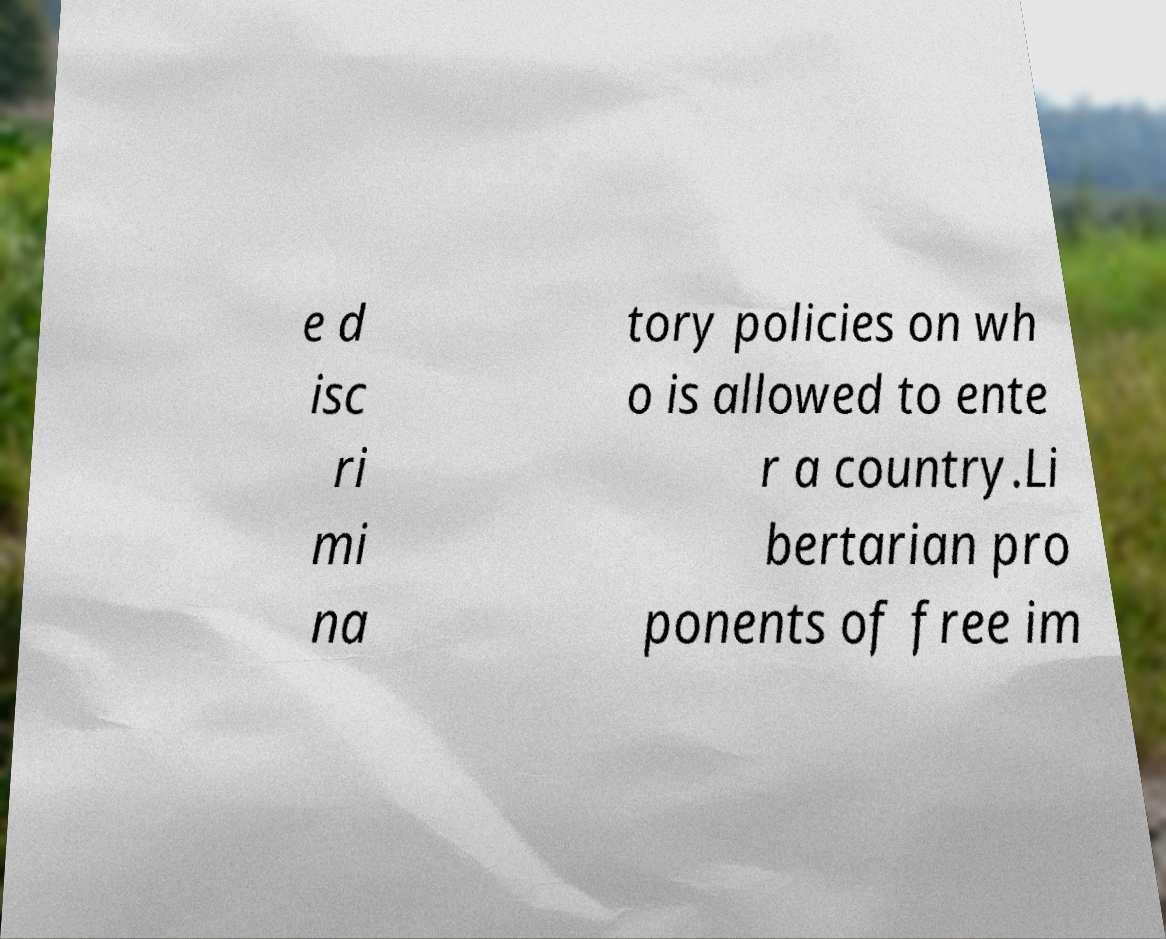Can you read and provide the text displayed in the image?This photo seems to have some interesting text. Can you extract and type it out for me? e d isc ri mi na tory policies on wh o is allowed to ente r a country.Li bertarian pro ponents of free im 